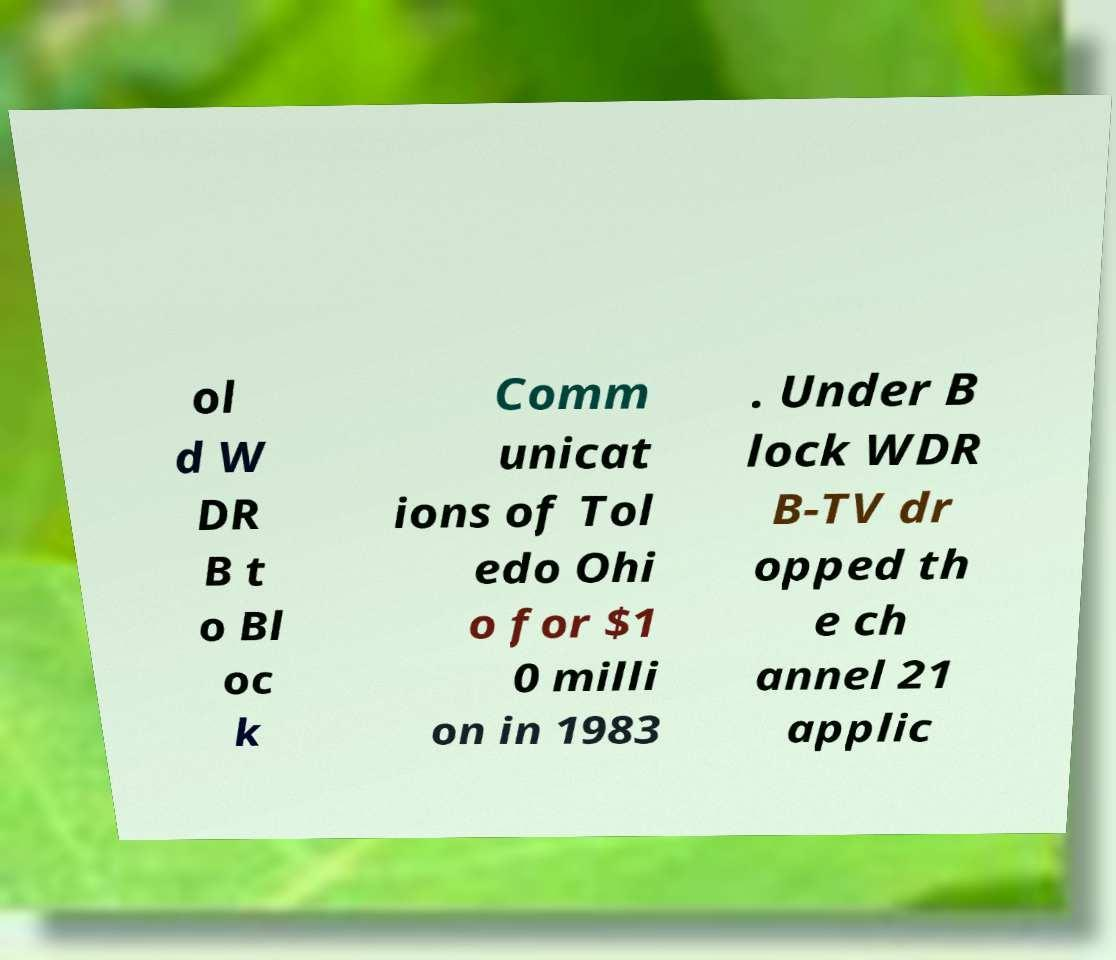There's text embedded in this image that I need extracted. Can you transcribe it verbatim? ol d W DR B t o Bl oc k Comm unicat ions of Tol edo Ohi o for $1 0 milli on in 1983 . Under B lock WDR B-TV dr opped th e ch annel 21 applic 